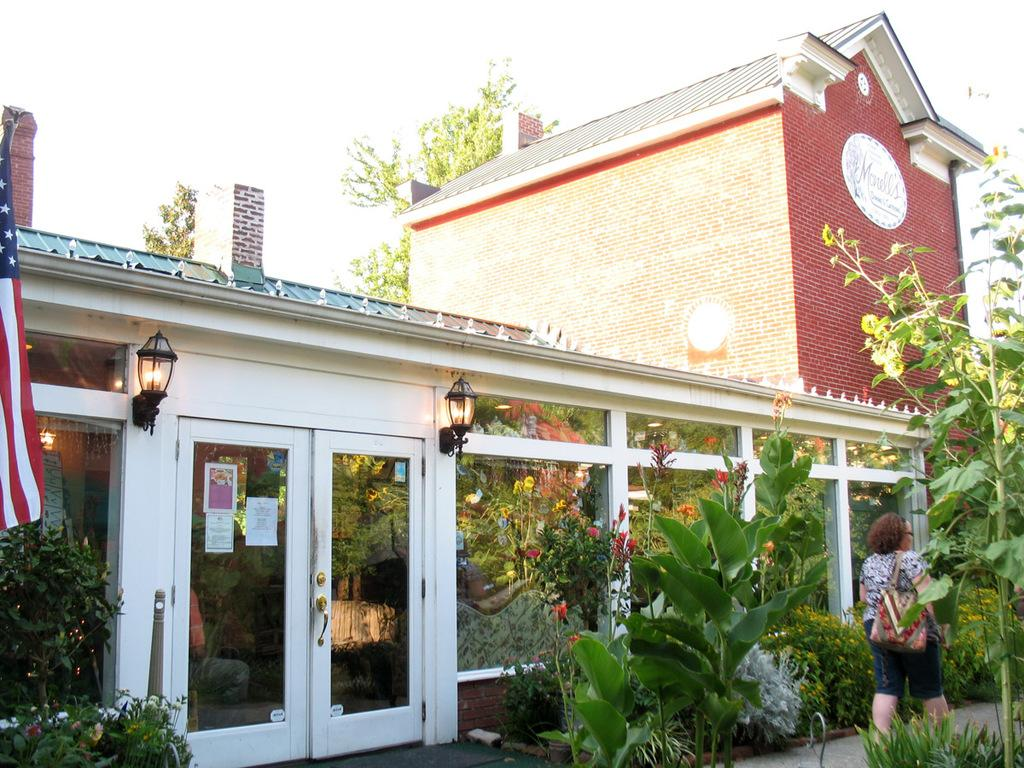What types of living organisms can be seen in the image? Plants and trees are visible in the image. Where is the flag located in the image? The flag is on the left side of the image. Can any structures be identified in the image? Yes, there is at least one building present in the image. What is visible in the background of the image? Trees and the sky are visible in the background of the image. What type of tent can be seen in the image? There is no tent present in the image. Can you hear any thunder in the image? The image is silent, and there is no indication of thunder or any sound. 